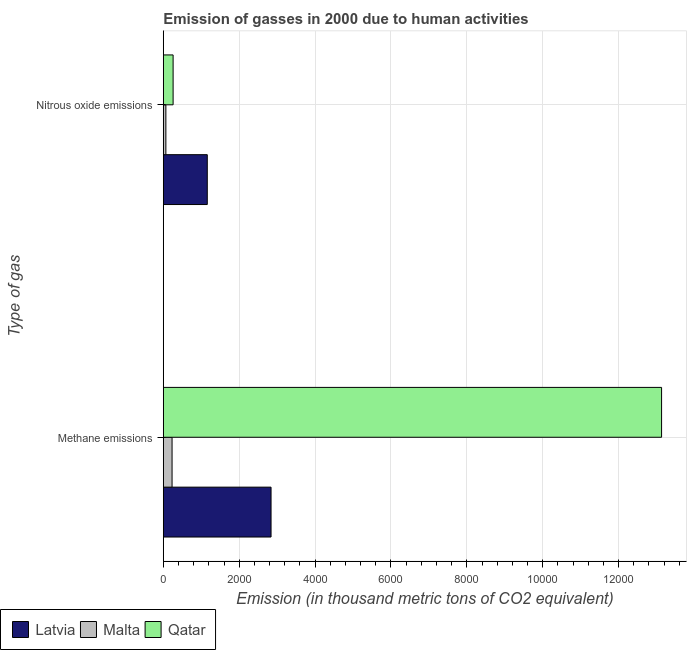How many different coloured bars are there?
Ensure brevity in your answer.  3. Are the number of bars per tick equal to the number of legend labels?
Offer a very short reply. Yes. How many bars are there on the 2nd tick from the top?
Provide a short and direct response. 3. What is the label of the 1st group of bars from the top?
Your answer should be compact. Nitrous oxide emissions. What is the amount of methane emissions in Latvia?
Keep it short and to the point. 2840. Across all countries, what is the maximum amount of methane emissions?
Offer a very short reply. 1.31e+04. Across all countries, what is the minimum amount of methane emissions?
Your response must be concise. 230.8. In which country was the amount of methane emissions maximum?
Give a very brief answer. Qatar. In which country was the amount of methane emissions minimum?
Make the answer very short. Malta. What is the total amount of methane emissions in the graph?
Offer a terse response. 1.62e+04. What is the difference between the amount of methane emissions in Malta and that in Latvia?
Make the answer very short. -2609.2. What is the difference between the amount of nitrous oxide emissions in Latvia and the amount of methane emissions in Malta?
Make the answer very short. 928.6. What is the average amount of nitrous oxide emissions per country?
Your response must be concise. 495.23. What is the difference between the amount of nitrous oxide emissions and amount of methane emissions in Latvia?
Give a very brief answer. -1680.6. In how many countries, is the amount of methane emissions greater than 6000 thousand metric tons?
Give a very brief answer. 1. What is the ratio of the amount of methane emissions in Latvia to that in Qatar?
Make the answer very short. 0.22. Is the amount of nitrous oxide emissions in Qatar less than that in Latvia?
Provide a succinct answer. Yes. What does the 3rd bar from the top in Methane emissions represents?
Make the answer very short. Latvia. What does the 3rd bar from the bottom in Nitrous oxide emissions represents?
Give a very brief answer. Qatar. Are all the bars in the graph horizontal?
Your answer should be very brief. Yes. Does the graph contain any zero values?
Your answer should be very brief. No. Where does the legend appear in the graph?
Provide a short and direct response. Bottom left. How many legend labels are there?
Offer a terse response. 3. How are the legend labels stacked?
Give a very brief answer. Horizontal. What is the title of the graph?
Offer a terse response. Emission of gasses in 2000 due to human activities. Does "Iraq" appear as one of the legend labels in the graph?
Provide a succinct answer. No. What is the label or title of the X-axis?
Ensure brevity in your answer.  Emission (in thousand metric tons of CO2 equivalent). What is the label or title of the Y-axis?
Your answer should be compact. Type of gas. What is the Emission (in thousand metric tons of CO2 equivalent) in Latvia in Methane emissions?
Offer a terse response. 2840. What is the Emission (in thousand metric tons of CO2 equivalent) of Malta in Methane emissions?
Your answer should be compact. 230.8. What is the Emission (in thousand metric tons of CO2 equivalent) of Qatar in Methane emissions?
Your response must be concise. 1.31e+04. What is the Emission (in thousand metric tons of CO2 equivalent) in Latvia in Nitrous oxide emissions?
Provide a succinct answer. 1159.4. What is the Emission (in thousand metric tons of CO2 equivalent) in Malta in Nitrous oxide emissions?
Provide a short and direct response. 67.7. What is the Emission (in thousand metric tons of CO2 equivalent) of Qatar in Nitrous oxide emissions?
Your answer should be compact. 258.6. Across all Type of gas, what is the maximum Emission (in thousand metric tons of CO2 equivalent) in Latvia?
Provide a succinct answer. 2840. Across all Type of gas, what is the maximum Emission (in thousand metric tons of CO2 equivalent) of Malta?
Offer a terse response. 230.8. Across all Type of gas, what is the maximum Emission (in thousand metric tons of CO2 equivalent) in Qatar?
Give a very brief answer. 1.31e+04. Across all Type of gas, what is the minimum Emission (in thousand metric tons of CO2 equivalent) of Latvia?
Offer a terse response. 1159.4. Across all Type of gas, what is the minimum Emission (in thousand metric tons of CO2 equivalent) of Malta?
Provide a short and direct response. 67.7. Across all Type of gas, what is the minimum Emission (in thousand metric tons of CO2 equivalent) in Qatar?
Your answer should be very brief. 258.6. What is the total Emission (in thousand metric tons of CO2 equivalent) of Latvia in the graph?
Offer a terse response. 3999.4. What is the total Emission (in thousand metric tons of CO2 equivalent) in Malta in the graph?
Give a very brief answer. 298.5. What is the total Emission (in thousand metric tons of CO2 equivalent) in Qatar in the graph?
Offer a terse response. 1.34e+04. What is the difference between the Emission (in thousand metric tons of CO2 equivalent) of Latvia in Methane emissions and that in Nitrous oxide emissions?
Offer a very short reply. 1680.6. What is the difference between the Emission (in thousand metric tons of CO2 equivalent) of Malta in Methane emissions and that in Nitrous oxide emissions?
Ensure brevity in your answer.  163.1. What is the difference between the Emission (in thousand metric tons of CO2 equivalent) of Qatar in Methane emissions and that in Nitrous oxide emissions?
Make the answer very short. 1.29e+04. What is the difference between the Emission (in thousand metric tons of CO2 equivalent) of Latvia in Methane emissions and the Emission (in thousand metric tons of CO2 equivalent) of Malta in Nitrous oxide emissions?
Provide a succinct answer. 2772.3. What is the difference between the Emission (in thousand metric tons of CO2 equivalent) of Latvia in Methane emissions and the Emission (in thousand metric tons of CO2 equivalent) of Qatar in Nitrous oxide emissions?
Keep it short and to the point. 2581.4. What is the difference between the Emission (in thousand metric tons of CO2 equivalent) in Malta in Methane emissions and the Emission (in thousand metric tons of CO2 equivalent) in Qatar in Nitrous oxide emissions?
Offer a terse response. -27.8. What is the average Emission (in thousand metric tons of CO2 equivalent) in Latvia per Type of gas?
Offer a very short reply. 1999.7. What is the average Emission (in thousand metric tons of CO2 equivalent) of Malta per Type of gas?
Ensure brevity in your answer.  149.25. What is the average Emission (in thousand metric tons of CO2 equivalent) in Qatar per Type of gas?
Provide a succinct answer. 6696.05. What is the difference between the Emission (in thousand metric tons of CO2 equivalent) of Latvia and Emission (in thousand metric tons of CO2 equivalent) of Malta in Methane emissions?
Ensure brevity in your answer.  2609.2. What is the difference between the Emission (in thousand metric tons of CO2 equivalent) in Latvia and Emission (in thousand metric tons of CO2 equivalent) in Qatar in Methane emissions?
Offer a very short reply. -1.03e+04. What is the difference between the Emission (in thousand metric tons of CO2 equivalent) in Malta and Emission (in thousand metric tons of CO2 equivalent) in Qatar in Methane emissions?
Offer a terse response. -1.29e+04. What is the difference between the Emission (in thousand metric tons of CO2 equivalent) of Latvia and Emission (in thousand metric tons of CO2 equivalent) of Malta in Nitrous oxide emissions?
Offer a terse response. 1091.7. What is the difference between the Emission (in thousand metric tons of CO2 equivalent) in Latvia and Emission (in thousand metric tons of CO2 equivalent) in Qatar in Nitrous oxide emissions?
Give a very brief answer. 900.8. What is the difference between the Emission (in thousand metric tons of CO2 equivalent) of Malta and Emission (in thousand metric tons of CO2 equivalent) of Qatar in Nitrous oxide emissions?
Keep it short and to the point. -190.9. What is the ratio of the Emission (in thousand metric tons of CO2 equivalent) in Latvia in Methane emissions to that in Nitrous oxide emissions?
Give a very brief answer. 2.45. What is the ratio of the Emission (in thousand metric tons of CO2 equivalent) in Malta in Methane emissions to that in Nitrous oxide emissions?
Your answer should be very brief. 3.41. What is the ratio of the Emission (in thousand metric tons of CO2 equivalent) of Qatar in Methane emissions to that in Nitrous oxide emissions?
Provide a short and direct response. 50.79. What is the difference between the highest and the second highest Emission (in thousand metric tons of CO2 equivalent) of Latvia?
Your response must be concise. 1680.6. What is the difference between the highest and the second highest Emission (in thousand metric tons of CO2 equivalent) in Malta?
Offer a very short reply. 163.1. What is the difference between the highest and the second highest Emission (in thousand metric tons of CO2 equivalent) of Qatar?
Offer a very short reply. 1.29e+04. What is the difference between the highest and the lowest Emission (in thousand metric tons of CO2 equivalent) in Latvia?
Provide a short and direct response. 1680.6. What is the difference between the highest and the lowest Emission (in thousand metric tons of CO2 equivalent) in Malta?
Give a very brief answer. 163.1. What is the difference between the highest and the lowest Emission (in thousand metric tons of CO2 equivalent) of Qatar?
Ensure brevity in your answer.  1.29e+04. 